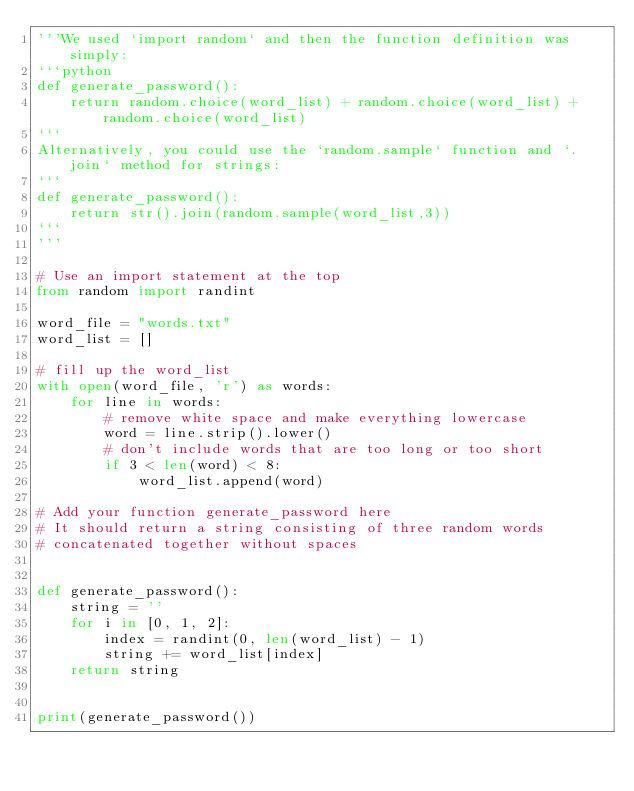Convert code to text. <code><loc_0><loc_0><loc_500><loc_500><_Python_>'''We used `import random` and then the function definition was simply:
```python
def generate_password():
	return random.choice(word_list) + random.choice(word_list) + random.choice(word_list)
```
Alternatively, you could use the `random.sample` function and `.join` method for strings:
```
def generate_password():
    return str().join(random.sample(word_list,3))
```
'''

# Use an import statement at the top
from random import randint

word_file = "words.txt"
word_list = []

# fill up the word_list
with open(word_file, 'r') as words:
    for line in words:
        # remove white space and make everything lowercase
        word = line.strip().lower()
        # don't include words that are too long or too short
        if 3 < len(word) < 8:
            word_list.append(word)

# Add your function generate_password here
# It should return a string consisting of three random words
# concatenated together without spaces


def generate_password():
    string = ''
    for i in [0, 1, 2]:
        index = randint(0, len(word_list) - 1)
        string += word_list[index]
    return string


print(generate_password())
</code> 